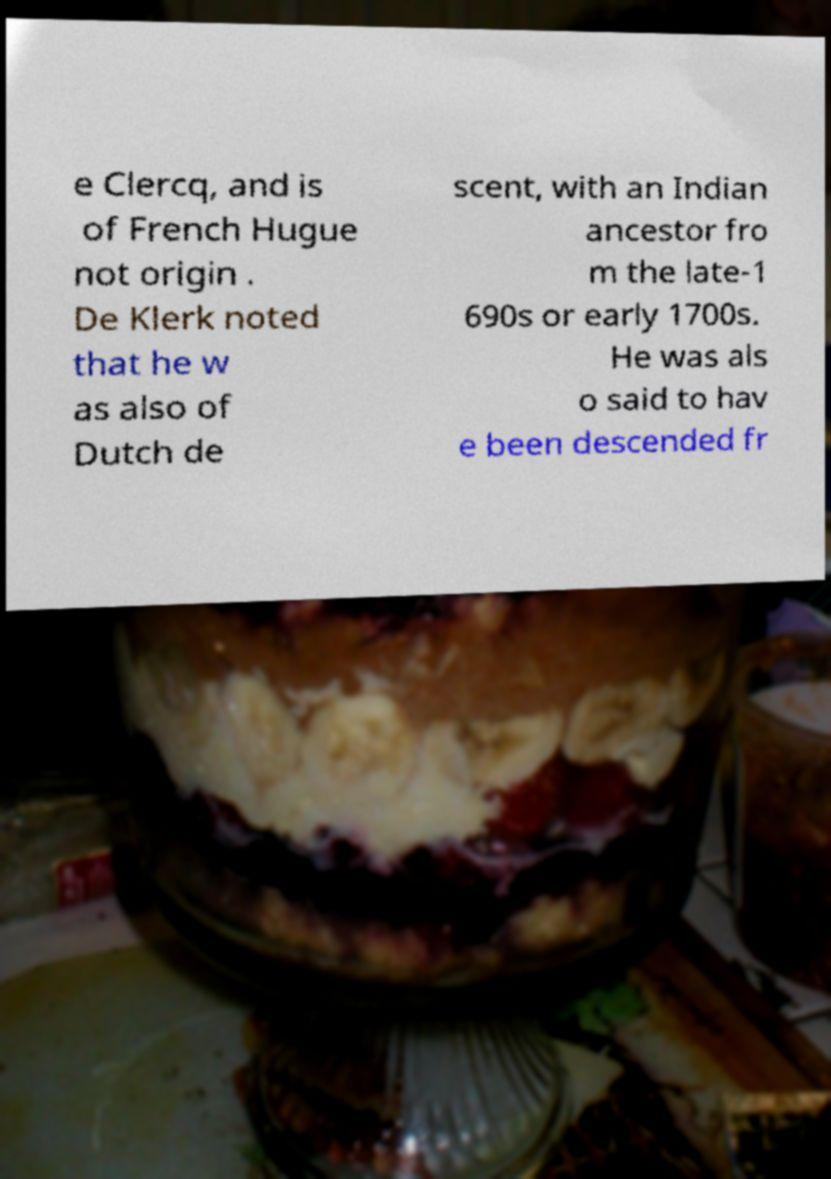Can you accurately transcribe the text from the provided image for me? e Clercq, and is of French Hugue not origin . De Klerk noted that he w as also of Dutch de scent, with an Indian ancestor fro m the late-1 690s or early 1700s. He was als o said to hav e been descended fr 